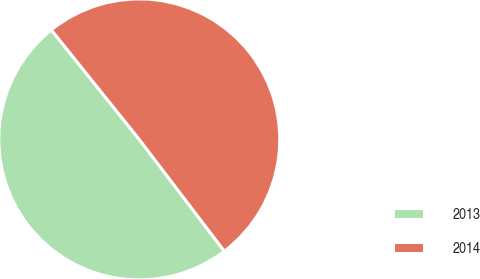Convert chart to OTSL. <chart><loc_0><loc_0><loc_500><loc_500><pie_chart><fcel>2013<fcel>2014<nl><fcel>49.59%<fcel>50.41%<nl></chart> 